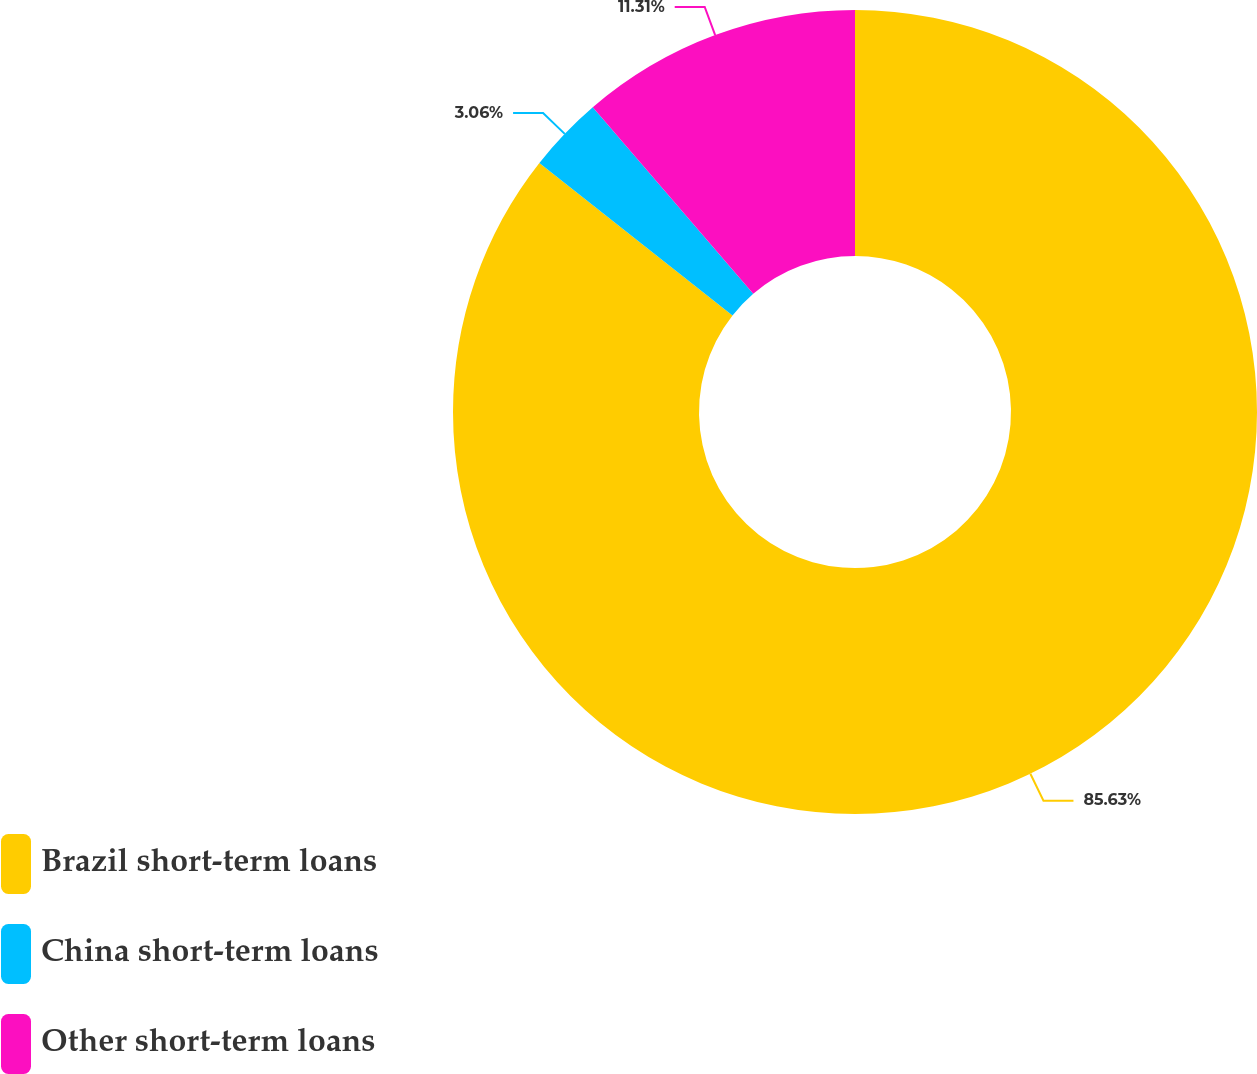<chart> <loc_0><loc_0><loc_500><loc_500><pie_chart><fcel>Brazil short-term loans<fcel>China short-term loans<fcel>Other short-term loans<nl><fcel>85.63%<fcel>3.06%<fcel>11.31%<nl></chart> 